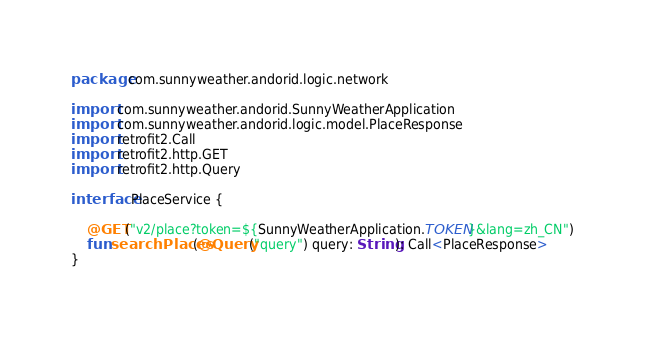Convert code to text. <code><loc_0><loc_0><loc_500><loc_500><_Kotlin_>package com.sunnyweather.andorid.logic.network

import com.sunnyweather.andorid.SunnyWeatherApplication
import com.sunnyweather.andorid.logic.model.PlaceResponse
import retrofit2.Call
import retrofit2.http.GET
import retrofit2.http.Query

interface PlaceService {

    @GET("v2/place?token=${SunnyWeatherApplication.TOKEN}&lang=zh_CN")
    fun searchPlaces(@Query("query") query: String): Call<PlaceResponse>
}</code> 